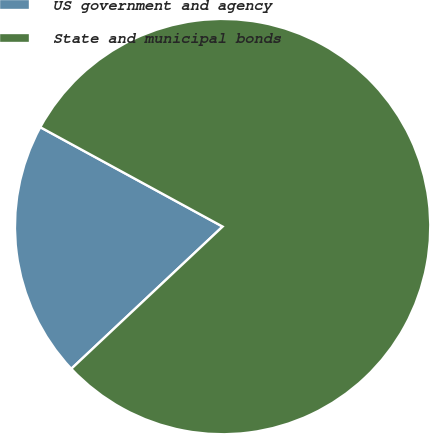Convert chart to OTSL. <chart><loc_0><loc_0><loc_500><loc_500><pie_chart><fcel>US government and agency<fcel>State and municipal bonds<nl><fcel>19.95%<fcel>80.05%<nl></chart> 